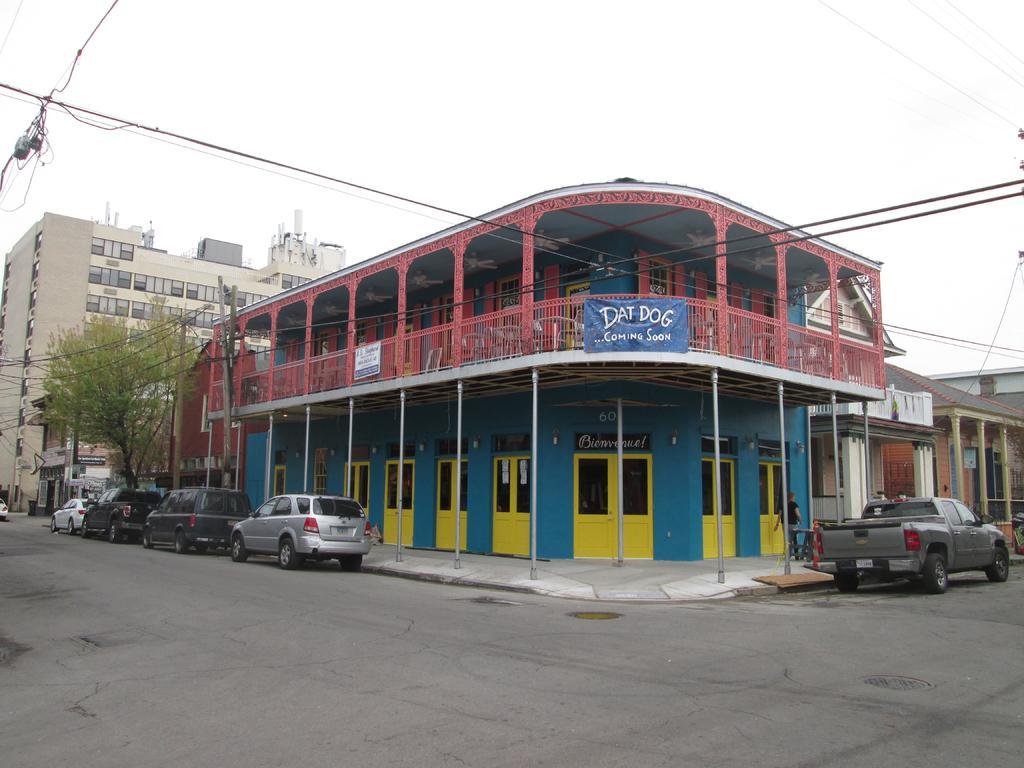In one or two sentences, can you explain what this image depicts? In the picture we can see the building with many doors which are yellow in color and some part of glasses to it and near to the building we can see some cars are parked and inside the building we can see a tree and another building with many floors and in the background we can see the sky. 